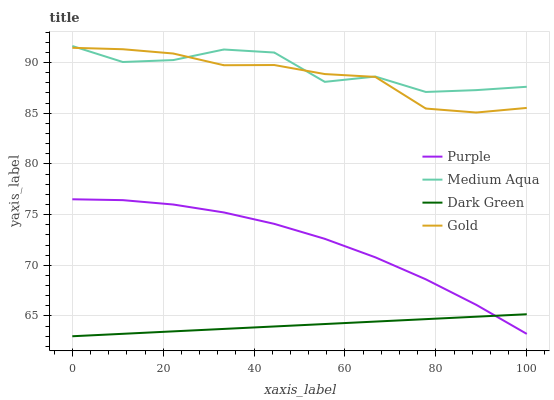Does Dark Green have the minimum area under the curve?
Answer yes or no. Yes. Does Medium Aqua have the maximum area under the curve?
Answer yes or no. Yes. Does Gold have the minimum area under the curve?
Answer yes or no. No. Does Gold have the maximum area under the curve?
Answer yes or no. No. Is Dark Green the smoothest?
Answer yes or no. Yes. Is Medium Aqua the roughest?
Answer yes or no. Yes. Is Gold the smoothest?
Answer yes or no. No. Is Gold the roughest?
Answer yes or no. No. Does Gold have the lowest value?
Answer yes or no. No. Does Gold have the highest value?
Answer yes or no. No. Is Purple less than Medium Aqua?
Answer yes or no. Yes. Is Medium Aqua greater than Purple?
Answer yes or no. Yes. Does Purple intersect Medium Aqua?
Answer yes or no. No. 